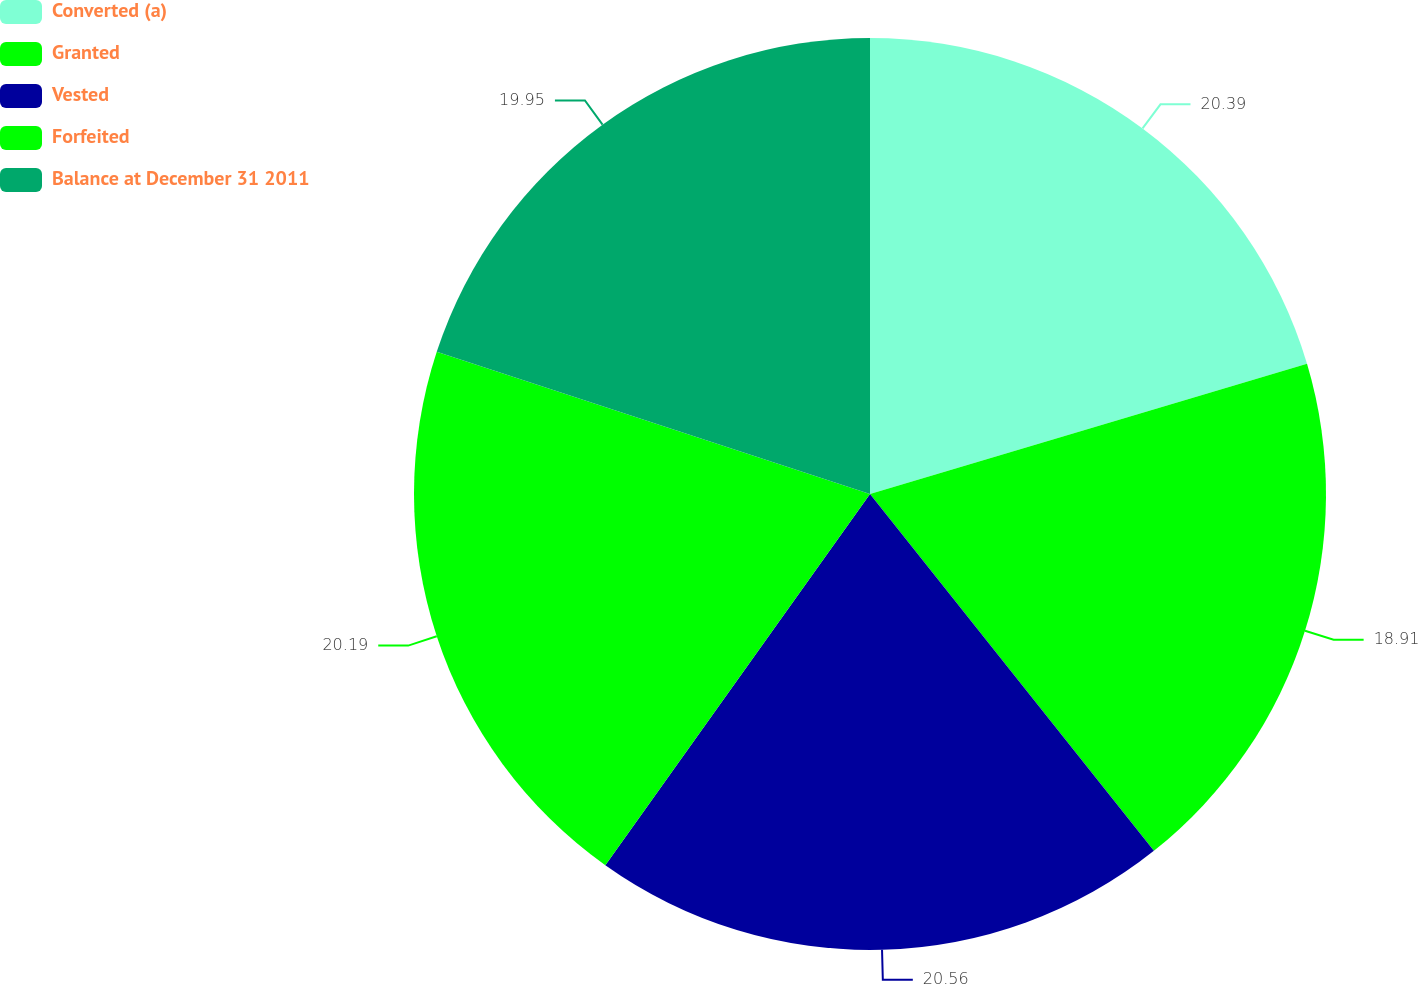<chart> <loc_0><loc_0><loc_500><loc_500><pie_chart><fcel>Converted (a)<fcel>Granted<fcel>Vested<fcel>Forfeited<fcel>Balance at December 31 2011<nl><fcel>20.39%<fcel>18.91%<fcel>20.55%<fcel>20.19%<fcel>19.95%<nl></chart> 